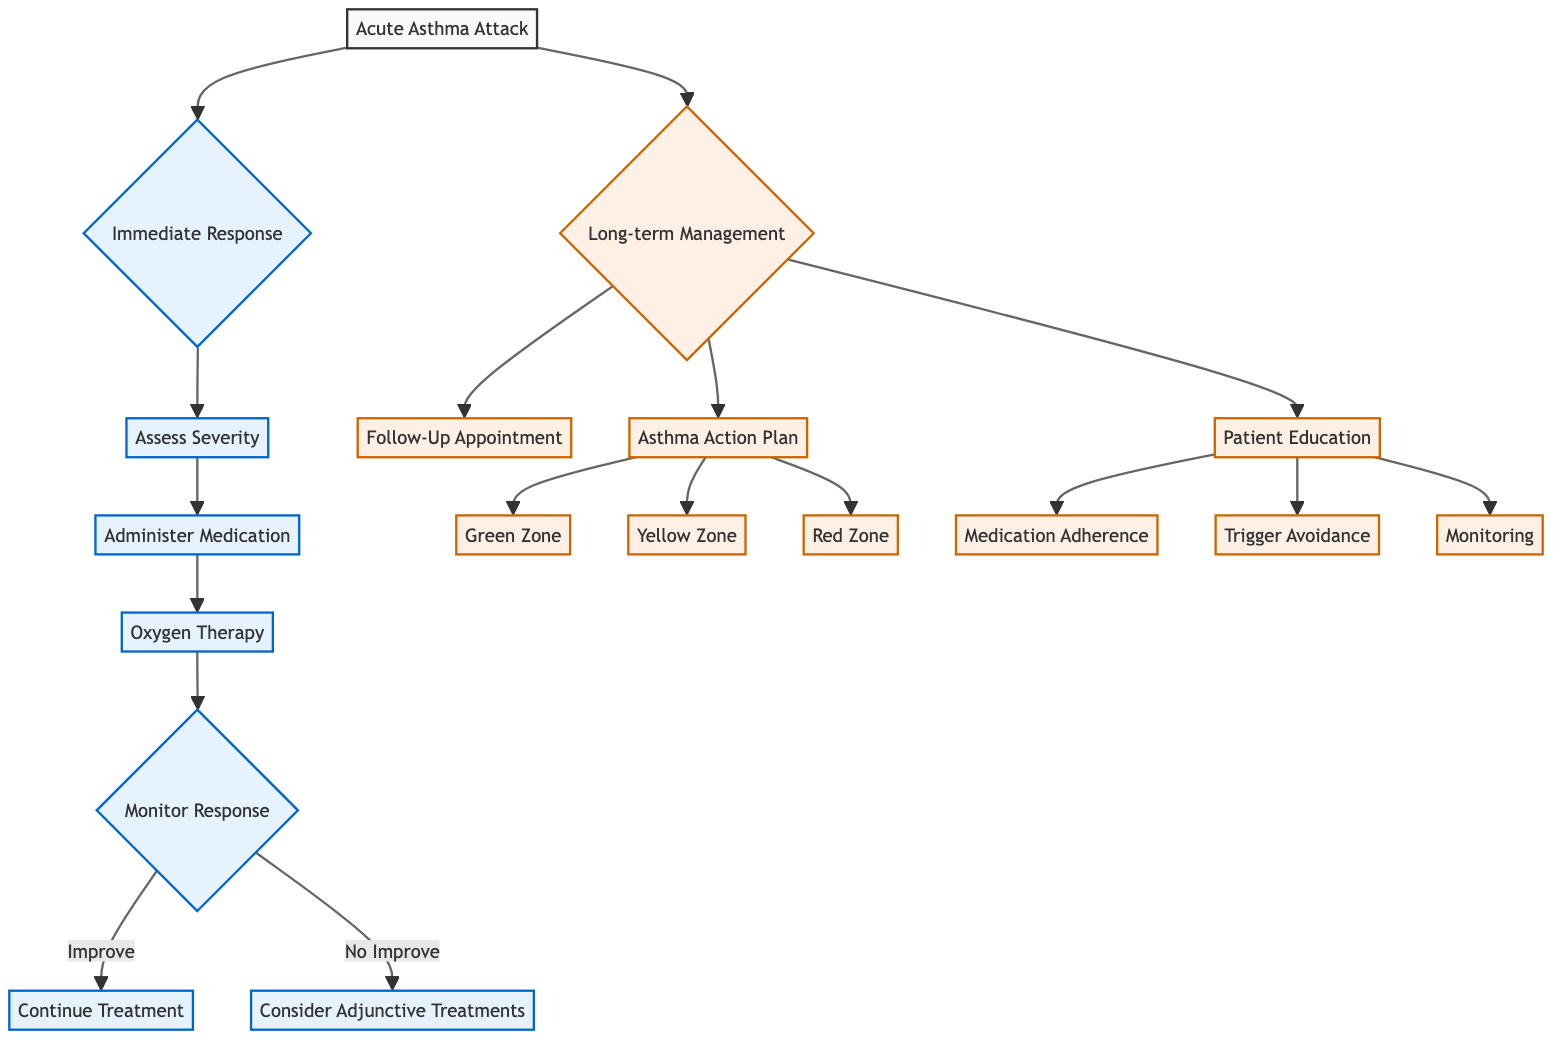What is the first step in the Immediate Response? The first step in the Immediate Response section of the diagram is "Assess Severity." It's the starting point that leads to subsequent actions based on the severity of the asthma attack.
Answer: Assess Severity How many steps are there in the Long-term Management section? The Long-term Management section contains three steps: Follow-Up Appointment, Asthma Action Plan, and Patient Education. Counting these gives a total of three steps in this section.
Answer: 3 What treatment is recommended for Moderate severity? For Moderate severity, the recommended treatment is "Inhaled SABA + oral corticosteroid, e.g., Prednisone, 40-60 mg." This is explicitly stated under the Administer Medication node for that severity level.
Answer: Inhaled SABA + oral corticosteroid, e.g., Prednisone, 40-60 mg What happens if the patient's status improves after monitoring? If the patient's status improves after monitoring, the action is to "Continue current treatment and reassess in 1 hour." This is the path laid out in the Monitor Response section of the diagram.
Answer: Continue current treatment and reassess in 1 hour Which zone indicates warning signs in the Asthma Action Plan? The Yellow Zone indicates warning signs. It is specifically mentioned in the Asthma Action Plan section of the diagram as a cautionary state where increased frequency of SABA is required.
Answer: Yellow Zone What is the main purpose of the Patient Education step? The main purpose of the Patient Education step is to inform patients about medication adherence, trigger avoidance, and monitoring. This step encompasses several crucial educational points for effective asthma management.
Answer: Importance of regular use of inhalers, identify and avoid known triggers, use peak flow meters regularly How many different responses can be monitored after the first treatment? After the first treatment, there are two possible responses that can be monitored: "Improve" or "No Improve." These responses dictate the immediate next steps as per the diagram's flow.
Answer: 2 What type of medication is used in the Green Zone of the Asthma Action Plan? The medication used in the Green Zone is "inhaled corticosteroids, e.g., Fluticasone." This is explicitly stated in the Asthma Action Plan as the daily management step for patients in this zone.
Answer: Inhaled corticosteroids, e.g., Fluticasone 